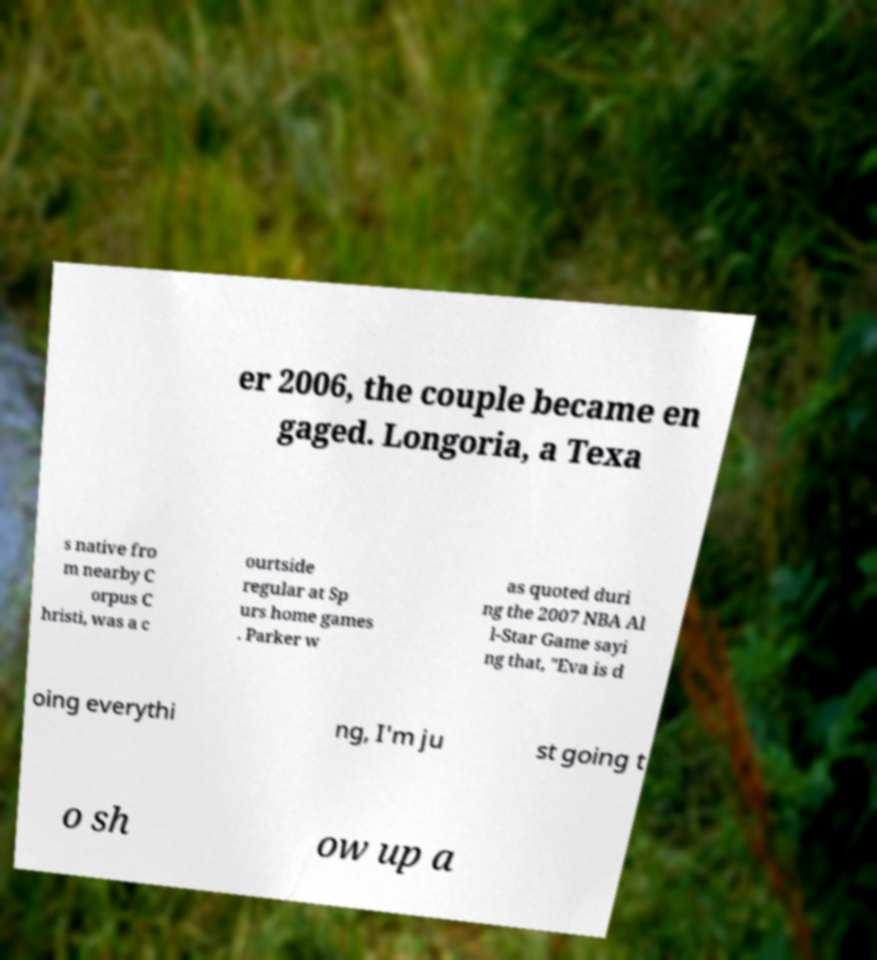For documentation purposes, I need the text within this image transcribed. Could you provide that? er 2006, the couple became en gaged. Longoria, a Texa s native fro m nearby C orpus C hristi, was a c ourtside regular at Sp urs home games . Parker w as quoted duri ng the 2007 NBA Al l-Star Game sayi ng that, "Eva is d oing everythi ng, I'm ju st going t o sh ow up a 